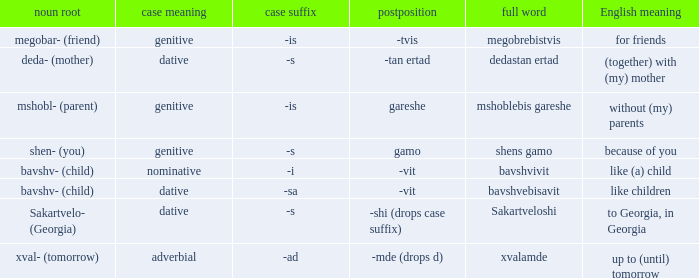What is English Meaning, when Full Word is "Shens Gamo"? Because of you. 